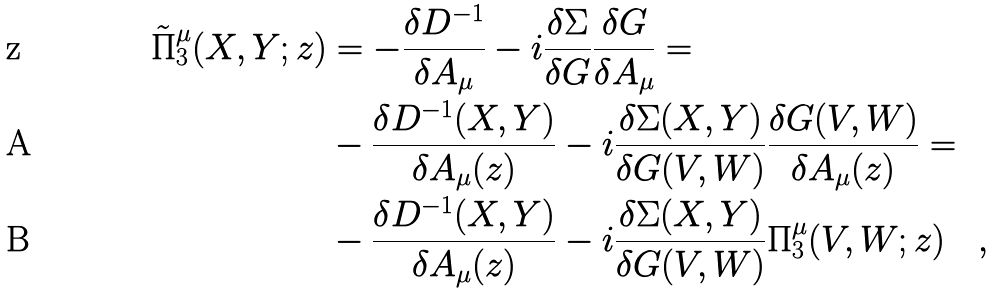Convert formula to latex. <formula><loc_0><loc_0><loc_500><loc_500>\tilde { \Pi } _ { 3 } ^ { \mu } ( X , Y ; z ) & = - \frac { \delta D ^ { - 1 } } { \delta A _ { \mu } } - i \frac { \delta \Sigma } { \delta G } \frac { \delta G } { \delta A _ { \mu } } = \\ & - \frac { \delta D ^ { - 1 } ( X , Y ) } { \delta A _ { \mu } ( z ) } - i \frac { \delta \Sigma ( X , Y ) } { \delta G ( V , W ) } \frac { \delta G ( V , W ) } { \delta A _ { \mu } ( z ) } = \\ & - \frac { \delta D ^ { - 1 } ( X , Y ) } { \delta A _ { \mu } ( z ) } - i \frac { \delta \Sigma ( X , Y ) } { \delta G ( V , W ) } \Pi _ { 3 } ^ { \mu } ( V , W ; z ) \quad ,</formula> 